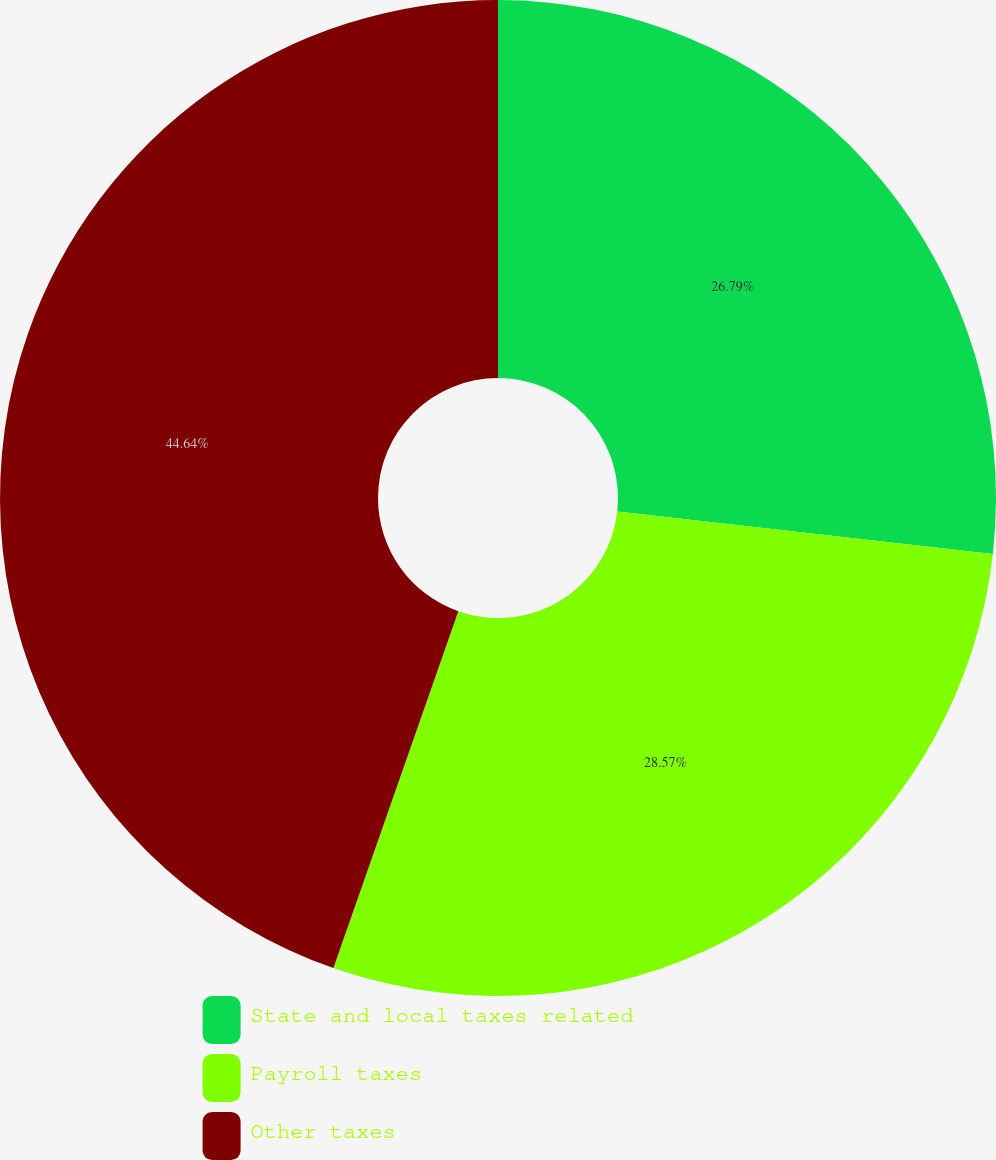Convert chart to OTSL. <chart><loc_0><loc_0><loc_500><loc_500><pie_chart><fcel>State and local taxes related<fcel>Payroll taxes<fcel>Other taxes<nl><fcel>26.79%<fcel>28.57%<fcel>44.64%<nl></chart> 